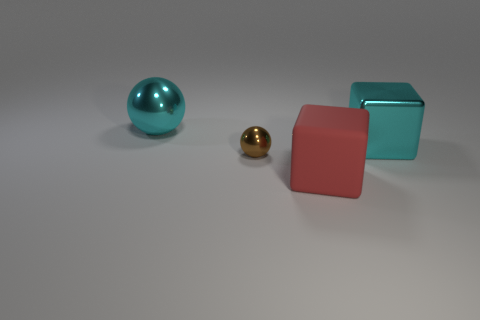What number of large things are either cyan objects or metallic objects?
Keep it short and to the point. 2. The brown ball has what size?
Ensure brevity in your answer.  Small. Are there more large things in front of the red matte object than balls?
Offer a very short reply. No. Are there the same number of big metal blocks that are on the left side of the metallic block and large cyan balls in front of the small brown metallic object?
Give a very brief answer. Yes. There is a thing that is in front of the cyan shiny block and behind the large rubber block; what color is it?
Your answer should be very brief. Brown. Is there any other thing that has the same size as the rubber cube?
Provide a short and direct response. Yes. Are there more rubber cubes on the right side of the large red block than blocks right of the large metallic cube?
Your answer should be compact. No. There is a sphere in front of the cyan cube; does it have the same size as the red thing?
Provide a succinct answer. No. How many large cyan balls are behind the big cyan object that is to the left of the tiny metallic ball behind the rubber cube?
Your response must be concise. 0. There is a object that is right of the tiny brown shiny thing and behind the small metal thing; what is its size?
Offer a very short reply. Large. 